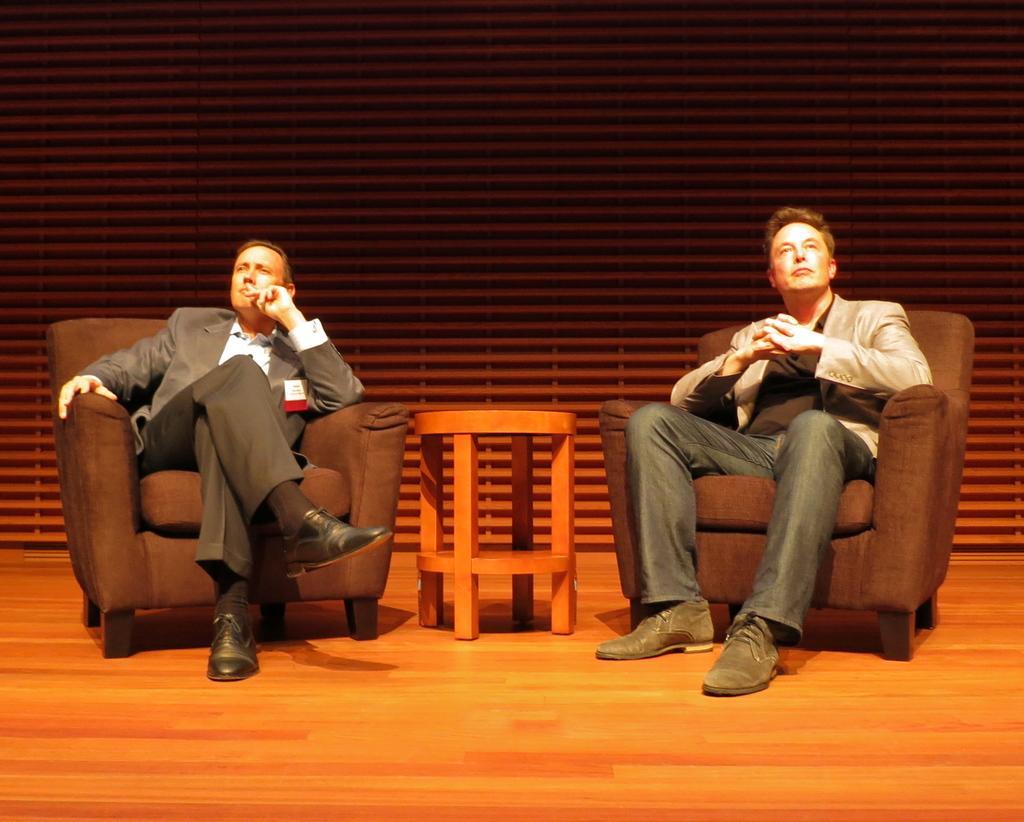Can you describe this image briefly? In this image I can see two persons sitting, the person at right is wearing cream color blazer, black shirt and black pant. The person at left is wearing gray blazer and black pant. I can also see a stool in brown color and I can see brown color background. 